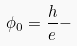<formula> <loc_0><loc_0><loc_500><loc_500>\phi _ { 0 } = \frac { h } { e } -</formula> 